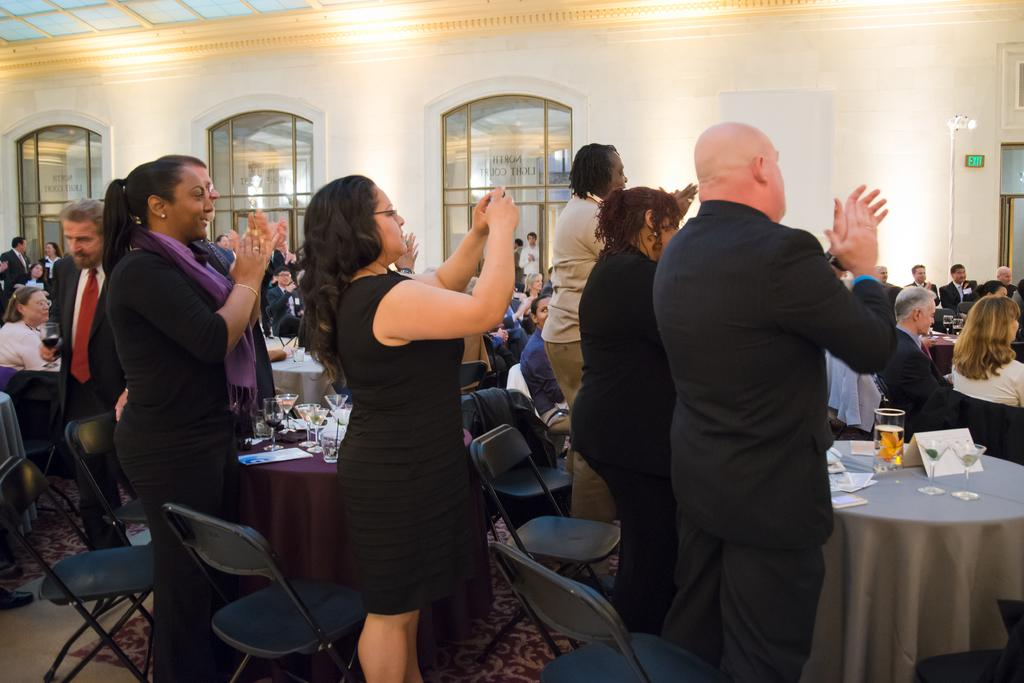Who is present in the image? There are people in the image, including men and women. Can you describe the gender distribution in the image? There are both men and women present in the image. What can be seen in the background of the image? There is a wall in the background of the image. What type of power source is visible in the image? There is no power source visible in the image; it only features people and a wall in the background. 